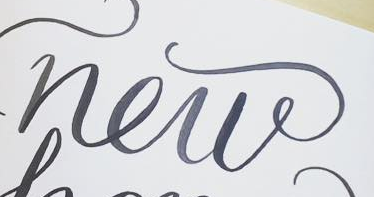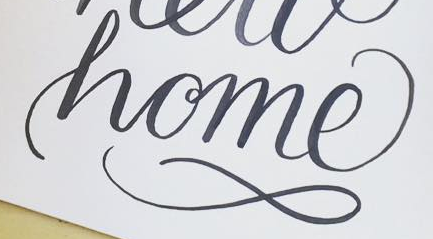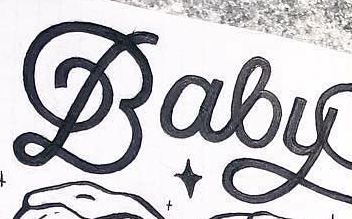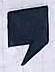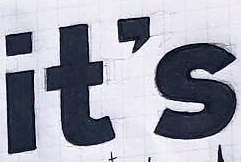What words can you see in these images in sequence, separated by a semicolon? new; home; Baby; ,; it's 